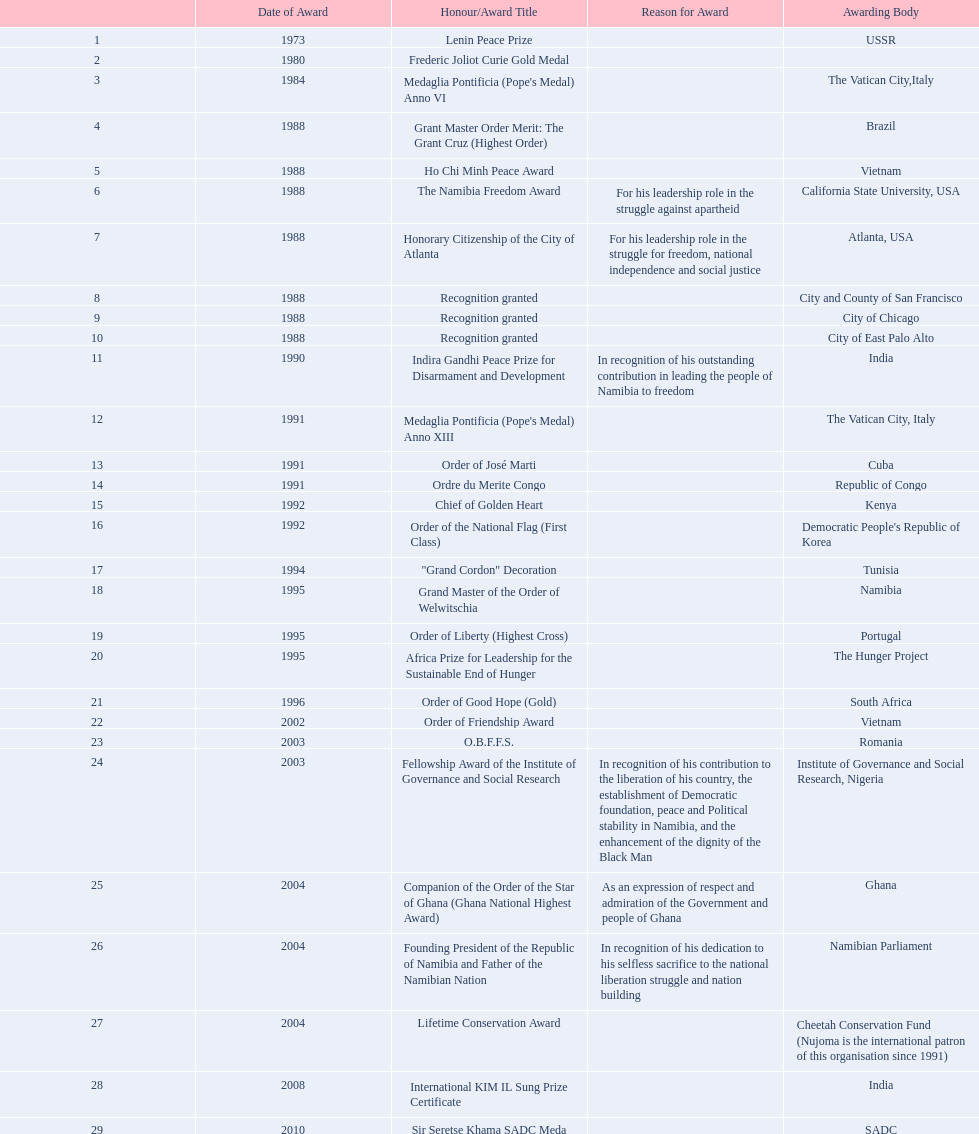Which awarding bodies have recognized sam nujoma? USSR, , The Vatican City,Italy, Brazil, Vietnam, California State University, USA, Atlanta, USA, City and County of San Francisco, City of Chicago, City of East Palo Alto, India, The Vatican City, Italy, Cuba, Republic of Congo, Kenya, Democratic People's Republic of Korea, Tunisia, Namibia, Portugal, The Hunger Project, South Africa, Vietnam, Romania, Institute of Governance and Social Research, Nigeria, Ghana, Namibian Parliament, Cheetah Conservation Fund (Nujoma is the international patron of this organisation since 1991), India, SADC. And what was the title of each award or honour? Lenin Peace Prize, Frederic Joliot Curie Gold Medal, Medaglia Pontificia (Pope's Medal) Anno VI, Grant Master Order Merit: The Grant Cruz (Highest Order), Ho Chi Minh Peace Award, The Namibia Freedom Award, Honorary Citizenship of the City of Atlanta, Recognition granted, Recognition granted, Recognition granted, Indira Gandhi Peace Prize for Disarmament and Development, Medaglia Pontificia (Pope's Medal) Anno XIII, Order of José Marti, Ordre du Merite Congo, Chief of Golden Heart, Order of the National Flag (First Class), "Grand Cordon" Decoration, Grand Master of the Order of Welwitschia, Order of Liberty (Highest Cross), Africa Prize for Leadership for the Sustainable End of Hunger, Order of Good Hope (Gold), Order of Friendship Award, O.B.F.F.S., Fellowship Award of the Institute of Governance and Social Research, Companion of the Order of the Star of Ghana (Ghana National Highest Award), Founding President of the Republic of Namibia and Father of the Namibian Nation, Lifetime Conservation Award, International KIM IL Sung Prize Certificate, Sir Seretse Khama SADC Meda. Of those, which nation awarded him the o.b.f.f.s.? Romania. 